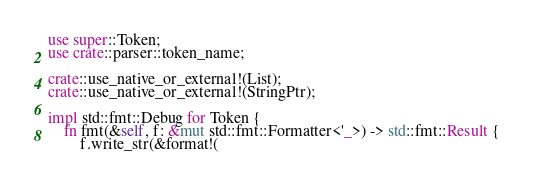Convert code to text. <code><loc_0><loc_0><loc_500><loc_500><_Rust_>use super::Token;
use crate::parser::token_name;

crate::use_native_or_external!(List);
crate::use_native_or_external!(StringPtr);

impl std::fmt::Debug for Token {
    fn fmt(&self, f: &mut std::fmt::Formatter<'_>) -> std::fmt::Result {
        f.write_str(&format!(</code> 